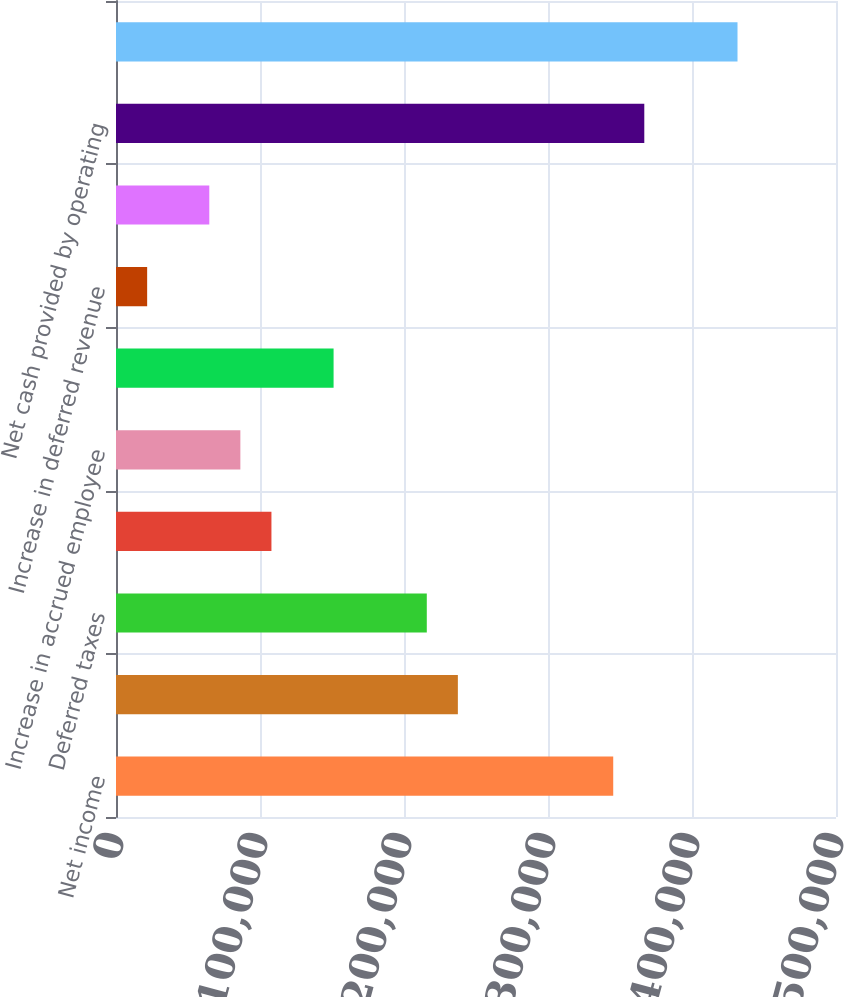<chart> <loc_0><loc_0><loc_500><loc_500><bar_chart><fcel>Net income<fcel>Depreciation and amortization<fcel>Deferred taxes<fcel>Other Changes in operating<fcel>Increase in accrued employee<fcel>Increase in income and other<fcel>Increase in deferred revenue<fcel>Increase (decrease) in<fcel>Net cash provided by operating<fcel>Proceeds from maturities and<nl><fcel>345294<fcel>237408<fcel>215831<fcel>107945<fcel>86367.8<fcel>151099<fcel>21636.2<fcel>64790.6<fcel>366871<fcel>431603<nl></chart> 